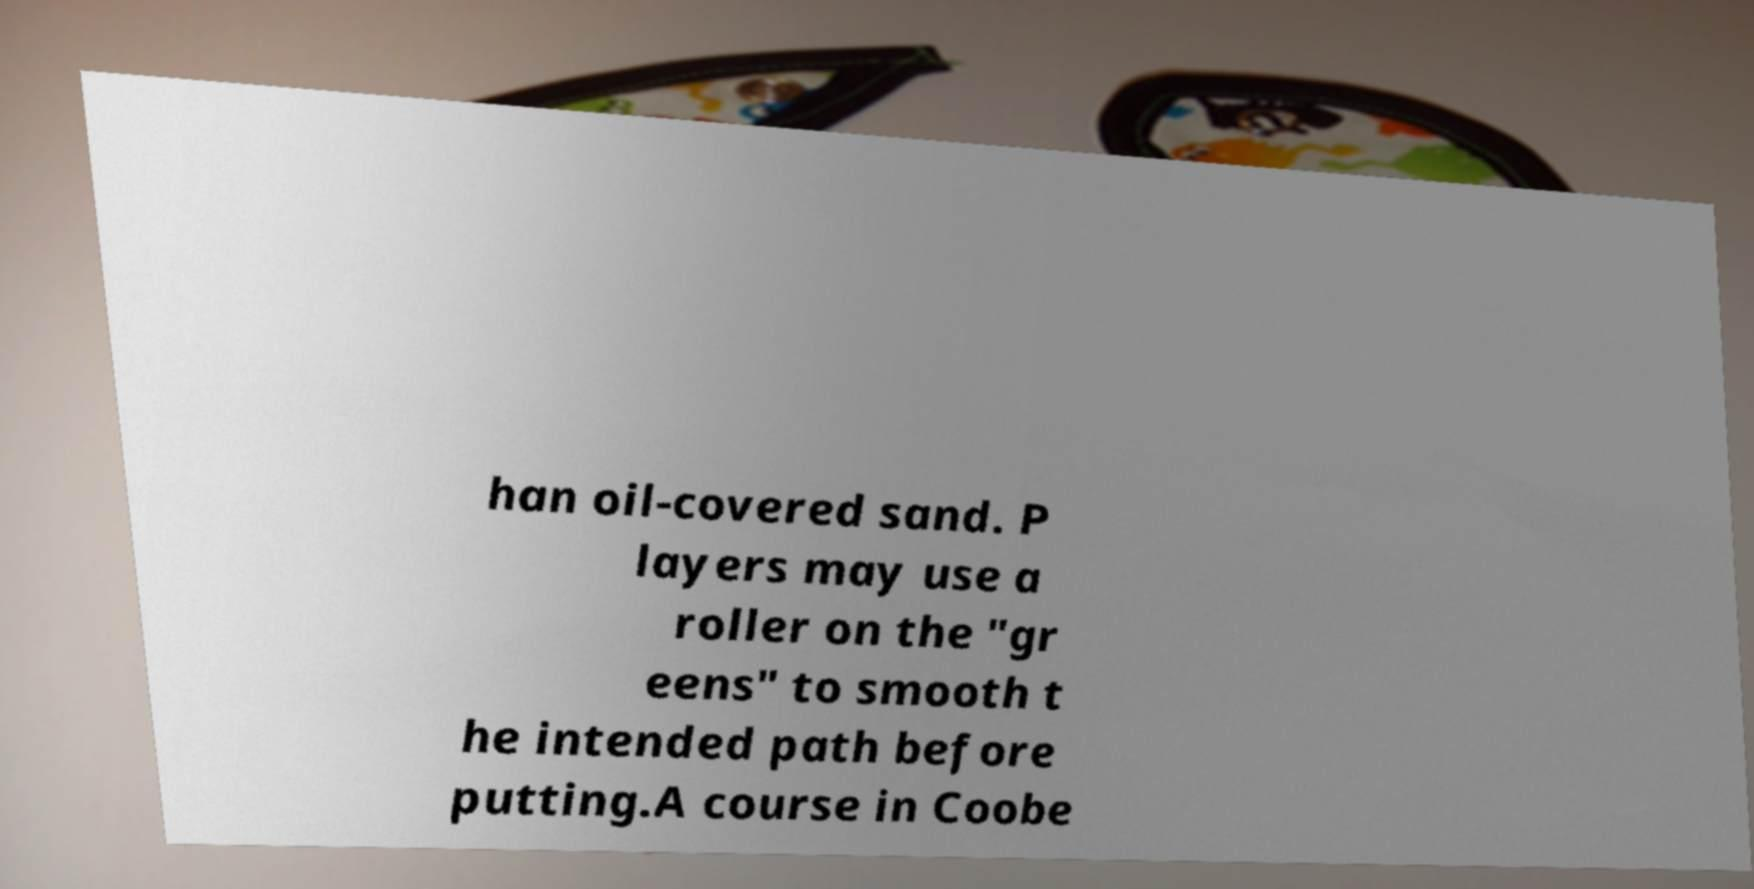Can you read and provide the text displayed in the image?This photo seems to have some interesting text. Can you extract and type it out for me? han oil-covered sand. P layers may use a roller on the "gr eens" to smooth t he intended path before putting.A course in Coobe 